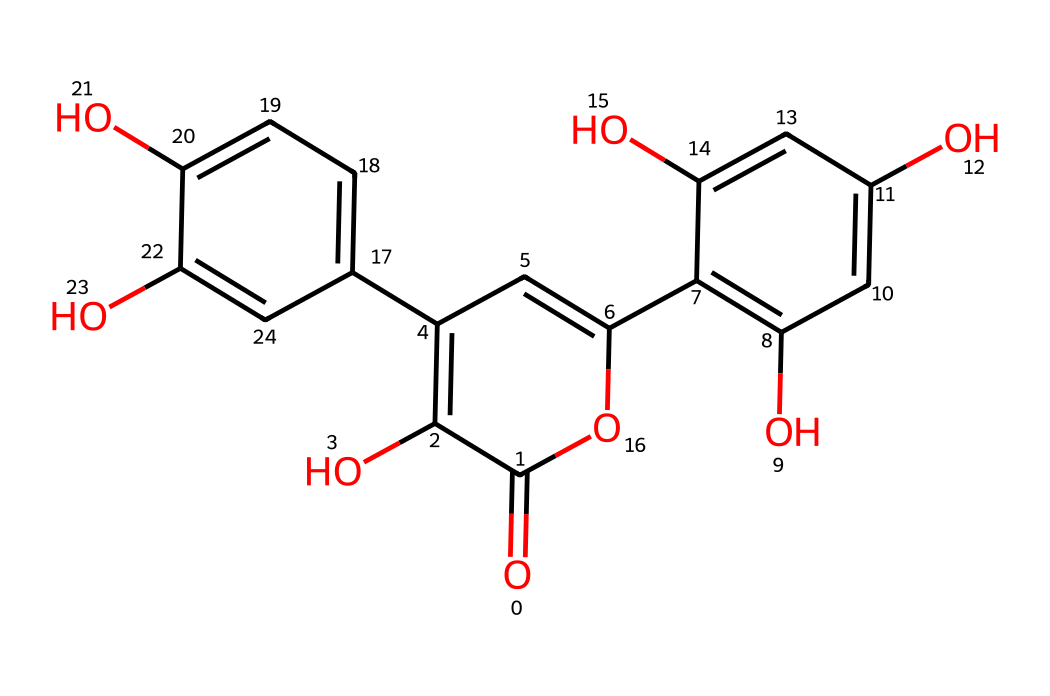What is the molecular formula of quercetin? The SMILES representation can be translated to reveal the molecular formula, which lists the types of atoms and their counts. Counting the carbon (C), hydrogen (H), and oxygen (O) atoms in the structure leads to a count of 15 carbons, 10 hydrogens, and 7 oxygens, giving the formula C15H10O7.
Answer: C15H10O7 How many hydroxyl (–OH) groups are present in quercetin? By analyzing the chemical structure, we locate the hydroxyl groups, which are represented as –OH. In the structure, there are 5 distinct –OH groups that are attached to the carbon framework.
Answer: 5 What type of compound is quercetin classified as? Quercetin features multiple hydroxyl groups and contains double bonds among its carbon atoms, indicating it is a flavonoid. Flavonoids are characterized by their polyphenolic structure.
Answer: flavonoid How many rings are present in the quercetin structure? In the structure derived from the SMILES, the rings can be identified by following the connections of the carbon atoms. Quercetin has 3 interconnected aromatic rings in its structure.
Answer: 3 Which chemical property does quercetin most notably exhibit due to its structure? The presence of multiple hydroxyl groups in the quercetin structure allows it to act as an antioxidant. These groups contribute to the ability to donate electrons or hydrogen, neutralizing free radicals.
Answer: antioxidant What is the total number of double bonds in quercetin? To determine the number of double bonds, we need to examine the connections between carbon atoms in the structure closely. Quercetin contains 6 double bonds among its carbon atoms, contributing to its stability and reactivity.
Answer: 6 What does the presence of multiple benzene-like rings indicate about quercetin's properties? The presence of multiple benzene-like rings, known for their delocalized electrons, suggests that quercetin has π-electron systems contributing to its antioxidant capabilities. These features enhance its ability to stabilize reactive species.
Answer: antioxidant capabilities 